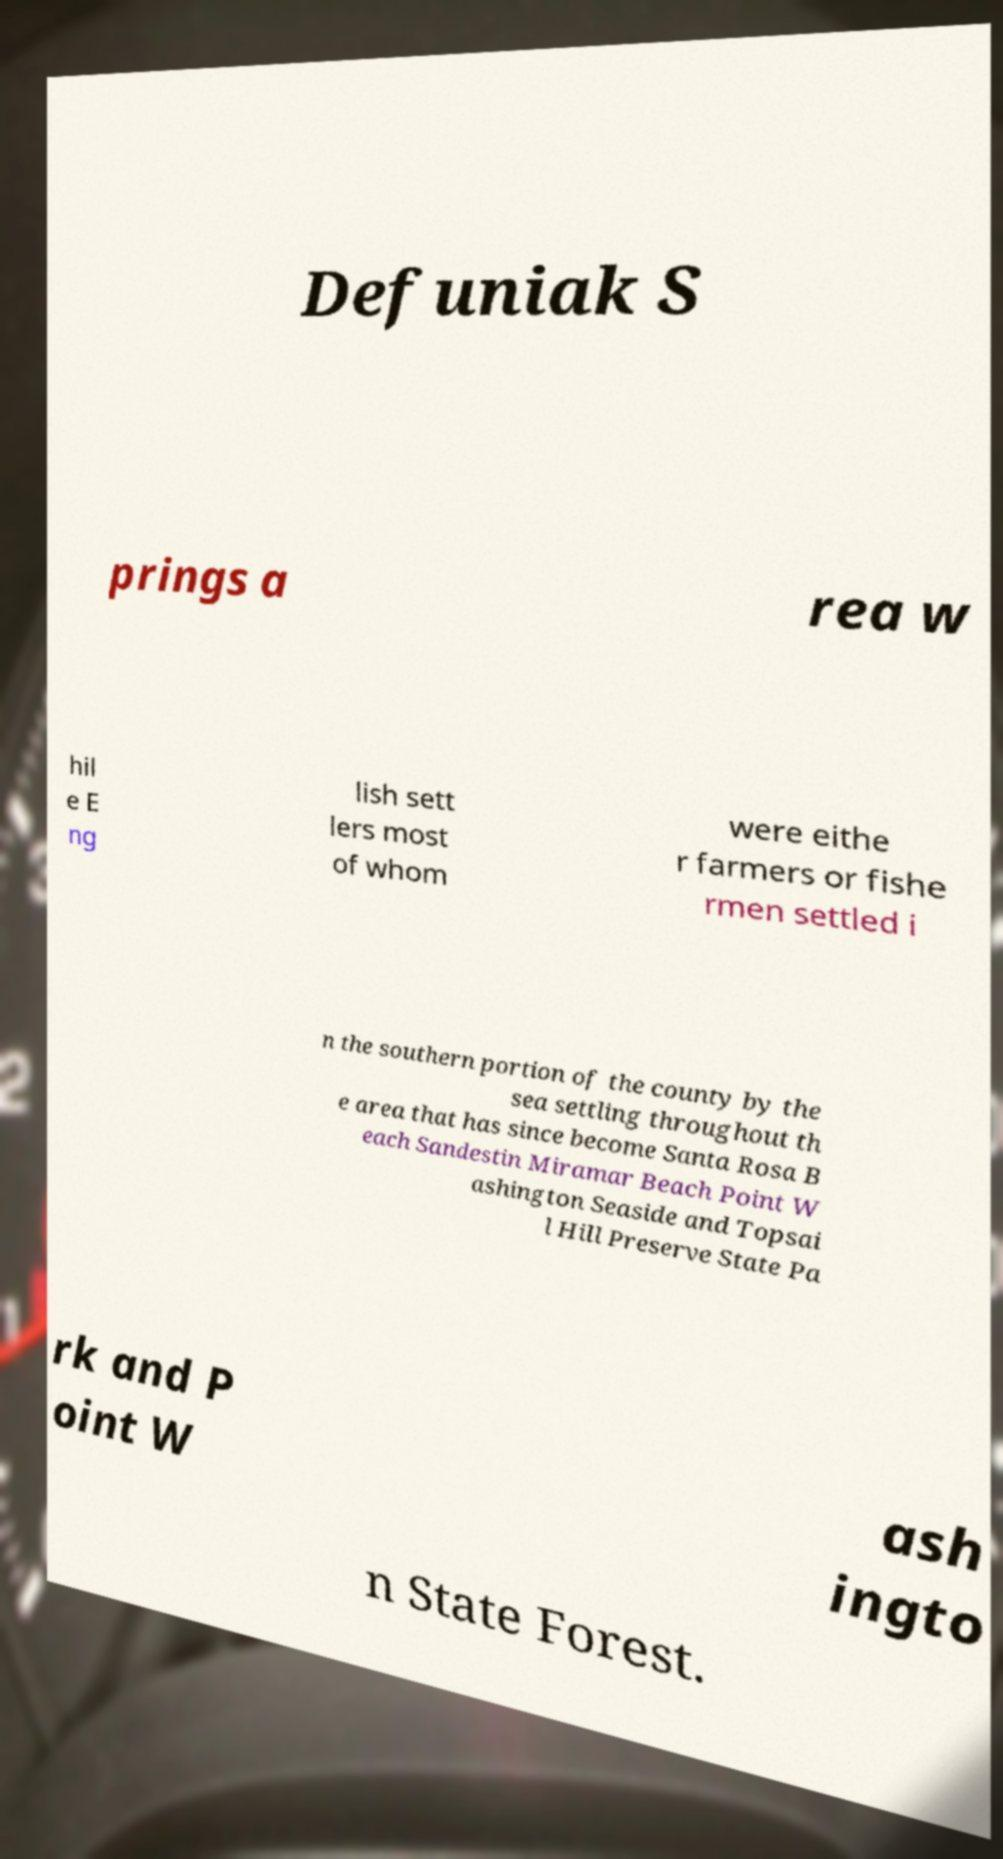Could you extract and type out the text from this image? Defuniak S prings a rea w hil e E ng lish sett lers most of whom were eithe r farmers or fishe rmen settled i n the southern portion of the county by the sea settling throughout th e area that has since become Santa Rosa B each Sandestin Miramar Beach Point W ashington Seaside and Topsai l Hill Preserve State Pa rk and P oint W ash ingto n State Forest. 